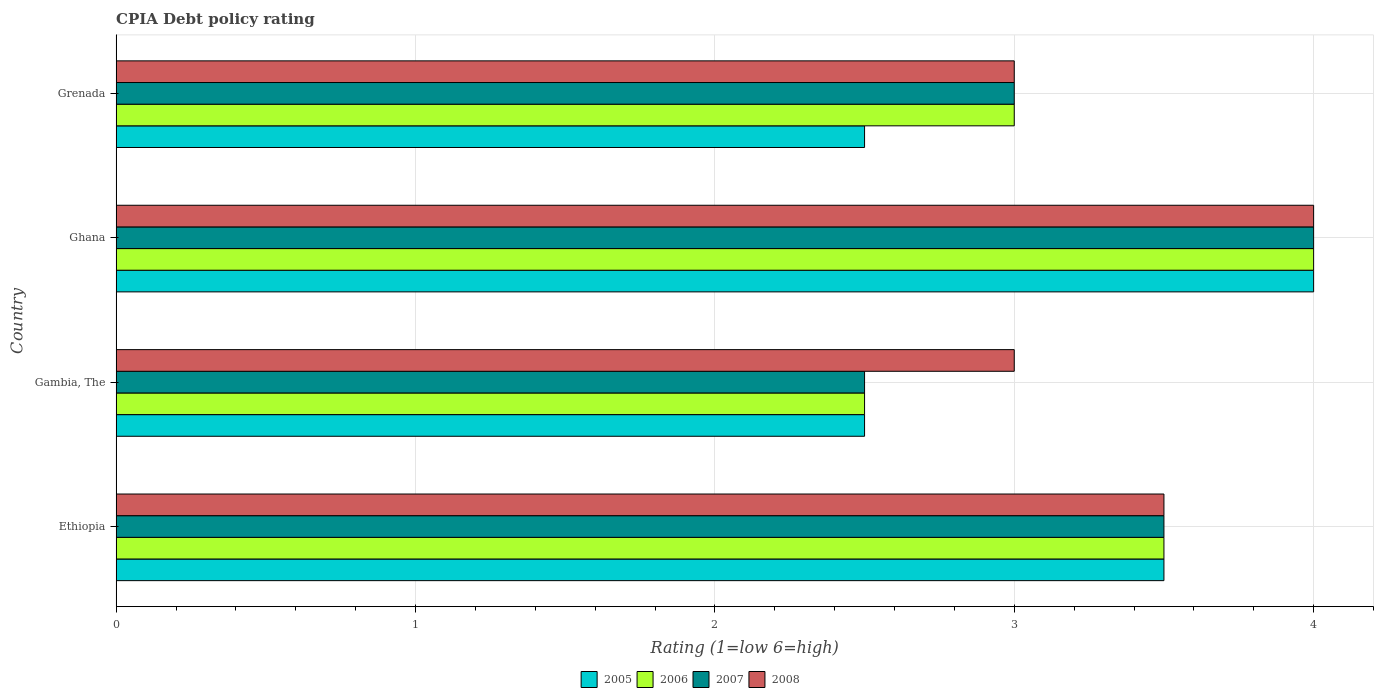How many different coloured bars are there?
Ensure brevity in your answer.  4. How many groups of bars are there?
Offer a terse response. 4. Are the number of bars per tick equal to the number of legend labels?
Your answer should be very brief. Yes. How many bars are there on the 3rd tick from the top?
Provide a succinct answer. 4. How many bars are there on the 4th tick from the bottom?
Make the answer very short. 4. What is the label of the 4th group of bars from the top?
Your answer should be compact. Ethiopia. In which country was the CPIA rating in 2007 minimum?
Keep it short and to the point. Gambia, The. What is the difference between the CPIA rating in 2008 in Gambia, The and that in Ghana?
Keep it short and to the point. -1. What is the difference between the CPIA rating in 2006 in Grenada and the CPIA rating in 2005 in Ethiopia?
Your answer should be very brief. -0.5. What is the average CPIA rating in 2008 per country?
Your answer should be very brief. 3.38. What is the difference between the CPIA rating in 2008 and CPIA rating in 2006 in Grenada?
Provide a succinct answer. 0. In how many countries, is the CPIA rating in 2007 greater than 4 ?
Give a very brief answer. 0. What is the ratio of the CPIA rating in 2006 in Ethiopia to that in Grenada?
Provide a short and direct response. 1.17. Is the CPIA rating in 2007 in Gambia, The less than that in Grenada?
Ensure brevity in your answer.  Yes. Is the difference between the CPIA rating in 2008 in Ethiopia and Grenada greater than the difference between the CPIA rating in 2006 in Ethiopia and Grenada?
Provide a short and direct response. No. What is the difference between the highest and the lowest CPIA rating in 2008?
Offer a very short reply. 1. In how many countries, is the CPIA rating in 2006 greater than the average CPIA rating in 2006 taken over all countries?
Provide a short and direct response. 2. What does the 1st bar from the top in Ethiopia represents?
Your response must be concise. 2008. What does the 3rd bar from the bottom in Ghana represents?
Offer a terse response. 2007. Is it the case that in every country, the sum of the CPIA rating in 2008 and CPIA rating in 2005 is greater than the CPIA rating in 2007?
Keep it short and to the point. Yes. How many bars are there?
Your answer should be compact. 16. How many countries are there in the graph?
Make the answer very short. 4. What is the difference between two consecutive major ticks on the X-axis?
Give a very brief answer. 1. How many legend labels are there?
Offer a very short reply. 4. How are the legend labels stacked?
Ensure brevity in your answer.  Horizontal. What is the title of the graph?
Make the answer very short. CPIA Debt policy rating. What is the label or title of the Y-axis?
Your response must be concise. Country. What is the Rating (1=low 6=high) in 2006 in Ethiopia?
Offer a terse response. 3.5. What is the Rating (1=low 6=high) of 2008 in Ethiopia?
Your answer should be compact. 3.5. What is the Rating (1=low 6=high) in 2005 in Gambia, The?
Offer a very short reply. 2.5. What is the Rating (1=low 6=high) in 2008 in Gambia, The?
Ensure brevity in your answer.  3. What is the Rating (1=low 6=high) of 2008 in Ghana?
Keep it short and to the point. 4. Across all countries, what is the maximum Rating (1=low 6=high) of 2006?
Ensure brevity in your answer.  4. Across all countries, what is the maximum Rating (1=low 6=high) of 2008?
Give a very brief answer. 4. Across all countries, what is the minimum Rating (1=low 6=high) of 2007?
Provide a short and direct response. 2.5. Across all countries, what is the minimum Rating (1=low 6=high) of 2008?
Provide a short and direct response. 3. What is the total Rating (1=low 6=high) of 2005 in the graph?
Provide a succinct answer. 12.5. What is the total Rating (1=low 6=high) in 2006 in the graph?
Offer a very short reply. 13. What is the total Rating (1=low 6=high) of 2007 in the graph?
Ensure brevity in your answer.  13. What is the difference between the Rating (1=low 6=high) in 2006 in Ethiopia and that in Gambia, The?
Your response must be concise. 1. What is the difference between the Rating (1=low 6=high) in 2007 in Ethiopia and that in Gambia, The?
Your answer should be compact. 1. What is the difference between the Rating (1=low 6=high) of 2008 in Ethiopia and that in Gambia, The?
Provide a succinct answer. 0.5. What is the difference between the Rating (1=low 6=high) of 2007 in Ethiopia and that in Ghana?
Give a very brief answer. -0.5. What is the difference between the Rating (1=low 6=high) in 2008 in Ethiopia and that in Ghana?
Give a very brief answer. -0.5. What is the difference between the Rating (1=low 6=high) in 2005 in Gambia, The and that in Ghana?
Offer a terse response. -1.5. What is the difference between the Rating (1=low 6=high) of 2006 in Gambia, The and that in Ghana?
Keep it short and to the point. -1.5. What is the difference between the Rating (1=low 6=high) in 2008 in Gambia, The and that in Ghana?
Your answer should be very brief. -1. What is the difference between the Rating (1=low 6=high) of 2008 in Gambia, The and that in Grenada?
Make the answer very short. 0. What is the difference between the Rating (1=low 6=high) in 2006 in Ghana and that in Grenada?
Give a very brief answer. 1. What is the difference between the Rating (1=low 6=high) in 2007 in Ghana and that in Grenada?
Your answer should be compact. 1. What is the difference between the Rating (1=low 6=high) in 2008 in Ghana and that in Grenada?
Ensure brevity in your answer.  1. What is the difference between the Rating (1=low 6=high) of 2005 in Ethiopia and the Rating (1=low 6=high) of 2007 in Gambia, The?
Offer a very short reply. 1. What is the difference between the Rating (1=low 6=high) of 2005 in Ethiopia and the Rating (1=low 6=high) of 2008 in Gambia, The?
Your answer should be compact. 0.5. What is the difference between the Rating (1=low 6=high) of 2005 in Ethiopia and the Rating (1=low 6=high) of 2006 in Ghana?
Make the answer very short. -0.5. What is the difference between the Rating (1=low 6=high) in 2005 in Ethiopia and the Rating (1=low 6=high) in 2007 in Ghana?
Provide a succinct answer. -0.5. What is the difference between the Rating (1=low 6=high) of 2006 in Ethiopia and the Rating (1=low 6=high) of 2008 in Ghana?
Make the answer very short. -0.5. What is the difference between the Rating (1=low 6=high) of 2007 in Ethiopia and the Rating (1=low 6=high) of 2008 in Ghana?
Give a very brief answer. -0.5. What is the difference between the Rating (1=low 6=high) in 2005 in Ethiopia and the Rating (1=low 6=high) in 2006 in Grenada?
Offer a terse response. 0.5. What is the difference between the Rating (1=low 6=high) in 2006 in Ethiopia and the Rating (1=low 6=high) in 2008 in Grenada?
Provide a succinct answer. 0.5. What is the difference between the Rating (1=low 6=high) in 2005 in Gambia, The and the Rating (1=low 6=high) in 2006 in Ghana?
Your answer should be compact. -1.5. What is the difference between the Rating (1=low 6=high) in 2005 in Gambia, The and the Rating (1=low 6=high) in 2007 in Ghana?
Your answer should be compact. -1.5. What is the difference between the Rating (1=low 6=high) of 2005 in Gambia, The and the Rating (1=low 6=high) of 2008 in Ghana?
Give a very brief answer. -1.5. What is the difference between the Rating (1=low 6=high) of 2006 in Gambia, The and the Rating (1=low 6=high) of 2007 in Ghana?
Offer a terse response. -1.5. What is the difference between the Rating (1=low 6=high) of 2006 in Gambia, The and the Rating (1=low 6=high) of 2008 in Ghana?
Your response must be concise. -1.5. What is the difference between the Rating (1=low 6=high) of 2007 in Gambia, The and the Rating (1=low 6=high) of 2008 in Ghana?
Provide a succinct answer. -1.5. What is the difference between the Rating (1=low 6=high) of 2005 in Gambia, The and the Rating (1=low 6=high) of 2006 in Grenada?
Make the answer very short. -0.5. What is the difference between the Rating (1=low 6=high) of 2005 in Gambia, The and the Rating (1=low 6=high) of 2008 in Grenada?
Give a very brief answer. -0.5. What is the difference between the Rating (1=low 6=high) in 2007 in Gambia, The and the Rating (1=low 6=high) in 2008 in Grenada?
Your response must be concise. -0.5. What is the difference between the Rating (1=low 6=high) of 2006 in Ghana and the Rating (1=low 6=high) of 2008 in Grenada?
Ensure brevity in your answer.  1. What is the difference between the Rating (1=low 6=high) of 2007 in Ghana and the Rating (1=low 6=high) of 2008 in Grenada?
Make the answer very short. 1. What is the average Rating (1=low 6=high) of 2005 per country?
Offer a terse response. 3.12. What is the average Rating (1=low 6=high) of 2008 per country?
Offer a terse response. 3.38. What is the difference between the Rating (1=low 6=high) in 2005 and Rating (1=low 6=high) in 2008 in Ethiopia?
Offer a very short reply. 0. What is the difference between the Rating (1=low 6=high) in 2007 and Rating (1=low 6=high) in 2008 in Ethiopia?
Give a very brief answer. 0. What is the difference between the Rating (1=low 6=high) in 2005 and Rating (1=low 6=high) in 2008 in Gambia, The?
Your answer should be compact. -0.5. What is the difference between the Rating (1=low 6=high) in 2007 and Rating (1=low 6=high) in 2008 in Gambia, The?
Offer a very short reply. -0.5. What is the difference between the Rating (1=low 6=high) in 2005 and Rating (1=low 6=high) in 2006 in Ghana?
Provide a short and direct response. 0. What is the difference between the Rating (1=low 6=high) in 2005 and Rating (1=low 6=high) in 2007 in Ghana?
Your answer should be compact. 0. What is the difference between the Rating (1=low 6=high) in 2005 and Rating (1=low 6=high) in 2006 in Grenada?
Provide a succinct answer. -0.5. What is the difference between the Rating (1=low 6=high) in 2005 and Rating (1=low 6=high) in 2007 in Grenada?
Offer a terse response. -0.5. What is the difference between the Rating (1=low 6=high) in 2005 and Rating (1=low 6=high) in 2008 in Grenada?
Ensure brevity in your answer.  -0.5. What is the ratio of the Rating (1=low 6=high) of 2005 in Ethiopia to that in Ghana?
Keep it short and to the point. 0.88. What is the ratio of the Rating (1=low 6=high) in 2006 in Ethiopia to that in Ghana?
Your answer should be very brief. 0.88. What is the ratio of the Rating (1=low 6=high) of 2007 in Ethiopia to that in Ghana?
Your answer should be very brief. 0.88. What is the ratio of the Rating (1=low 6=high) in 2008 in Ethiopia to that in Ghana?
Offer a very short reply. 0.88. What is the ratio of the Rating (1=low 6=high) in 2006 in Ethiopia to that in Grenada?
Offer a very short reply. 1.17. What is the ratio of the Rating (1=low 6=high) of 2008 in Ethiopia to that in Grenada?
Provide a succinct answer. 1.17. What is the ratio of the Rating (1=low 6=high) in 2005 in Gambia, The to that in Ghana?
Provide a succinct answer. 0.62. What is the ratio of the Rating (1=low 6=high) of 2006 in Gambia, The to that in Ghana?
Give a very brief answer. 0.62. What is the ratio of the Rating (1=low 6=high) in 2008 in Gambia, The to that in Ghana?
Make the answer very short. 0.75. What is the ratio of the Rating (1=low 6=high) of 2005 in Gambia, The to that in Grenada?
Provide a short and direct response. 1. What is the ratio of the Rating (1=low 6=high) in 2006 in Gambia, The to that in Grenada?
Your answer should be very brief. 0.83. What is the ratio of the Rating (1=low 6=high) in 2007 in Ghana to that in Grenada?
Your answer should be compact. 1.33. What is the ratio of the Rating (1=low 6=high) in 2008 in Ghana to that in Grenada?
Make the answer very short. 1.33. What is the difference between the highest and the second highest Rating (1=low 6=high) in 2005?
Offer a very short reply. 0.5. What is the difference between the highest and the second highest Rating (1=low 6=high) of 2006?
Your answer should be very brief. 0.5. What is the difference between the highest and the second highest Rating (1=low 6=high) in 2008?
Your response must be concise. 0.5. What is the difference between the highest and the lowest Rating (1=low 6=high) in 2006?
Offer a very short reply. 1.5. 